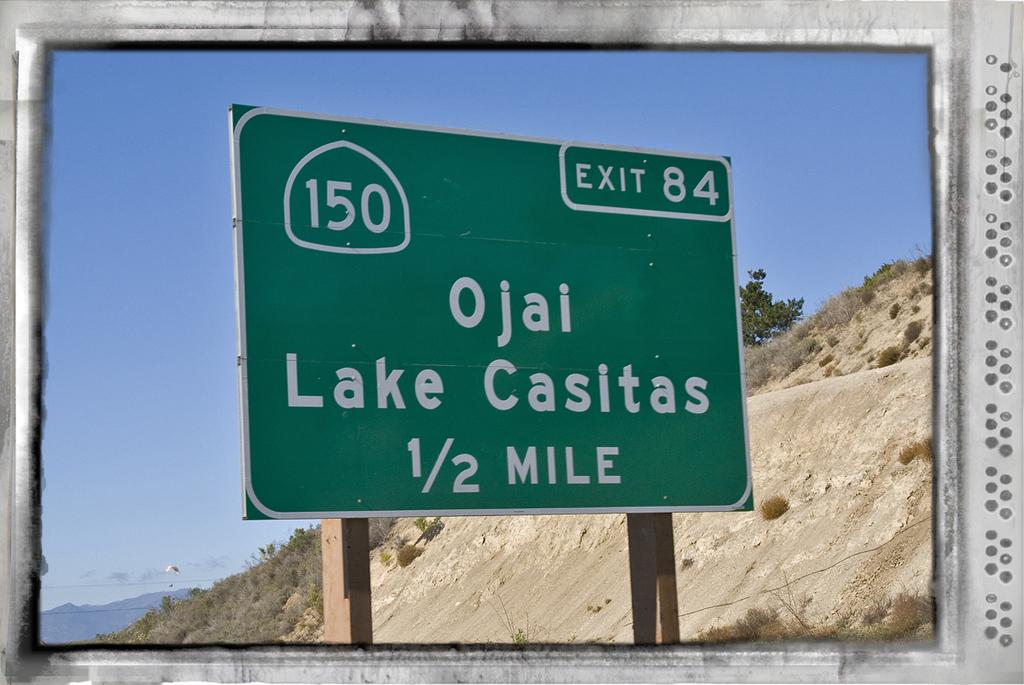<image>
Render a clear and concise summary of the photo. an Ojai sign outside in the middle of the day 